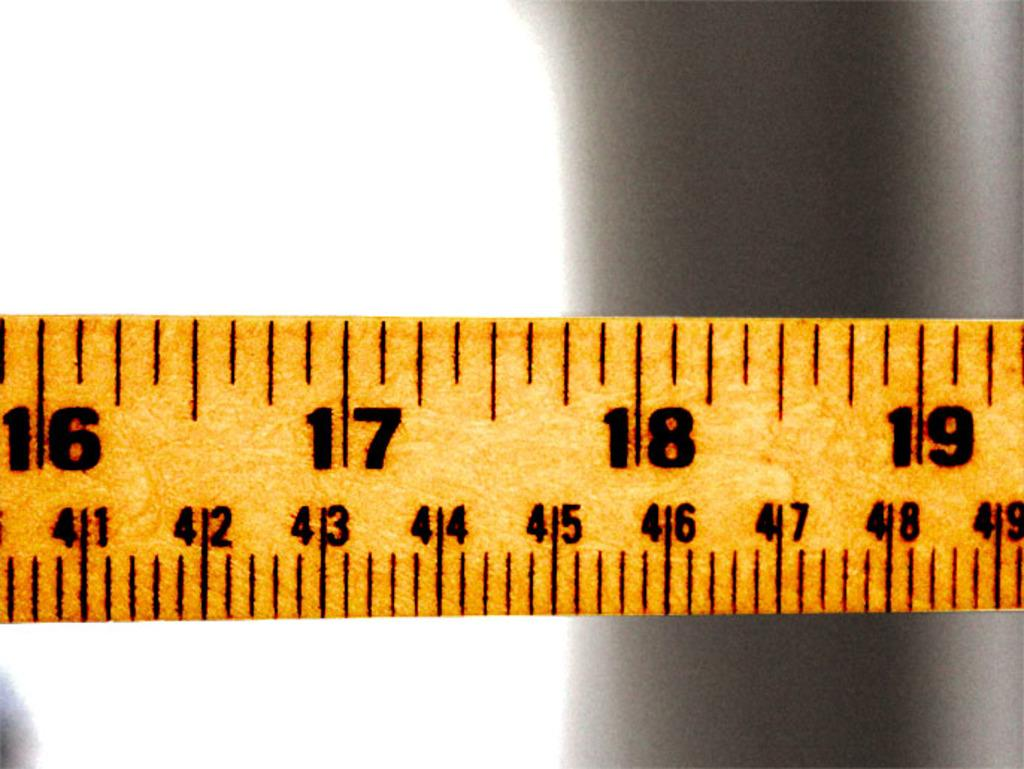<image>
Write a terse but informative summary of the picture. A tape measure shows between 16 and 19 inches. 